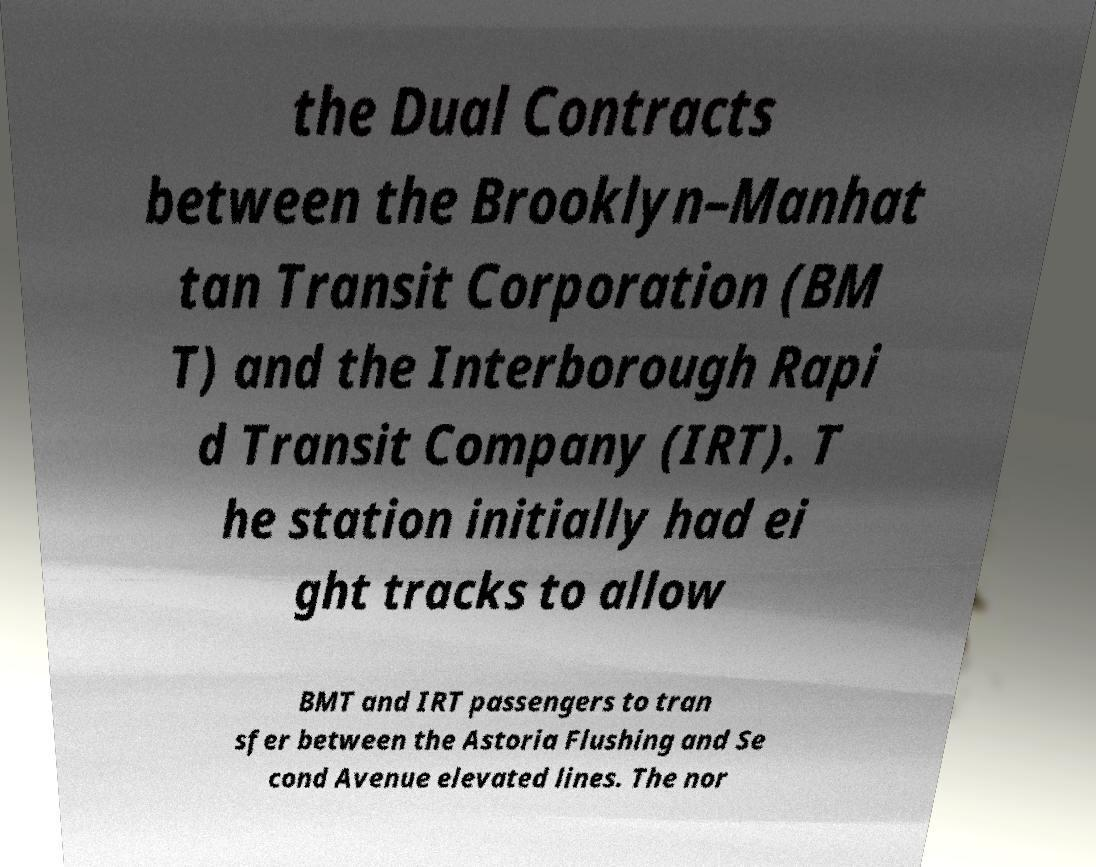Please identify and transcribe the text found in this image. the Dual Contracts between the Brooklyn–Manhat tan Transit Corporation (BM T) and the Interborough Rapi d Transit Company (IRT). T he station initially had ei ght tracks to allow BMT and IRT passengers to tran sfer between the Astoria Flushing and Se cond Avenue elevated lines. The nor 